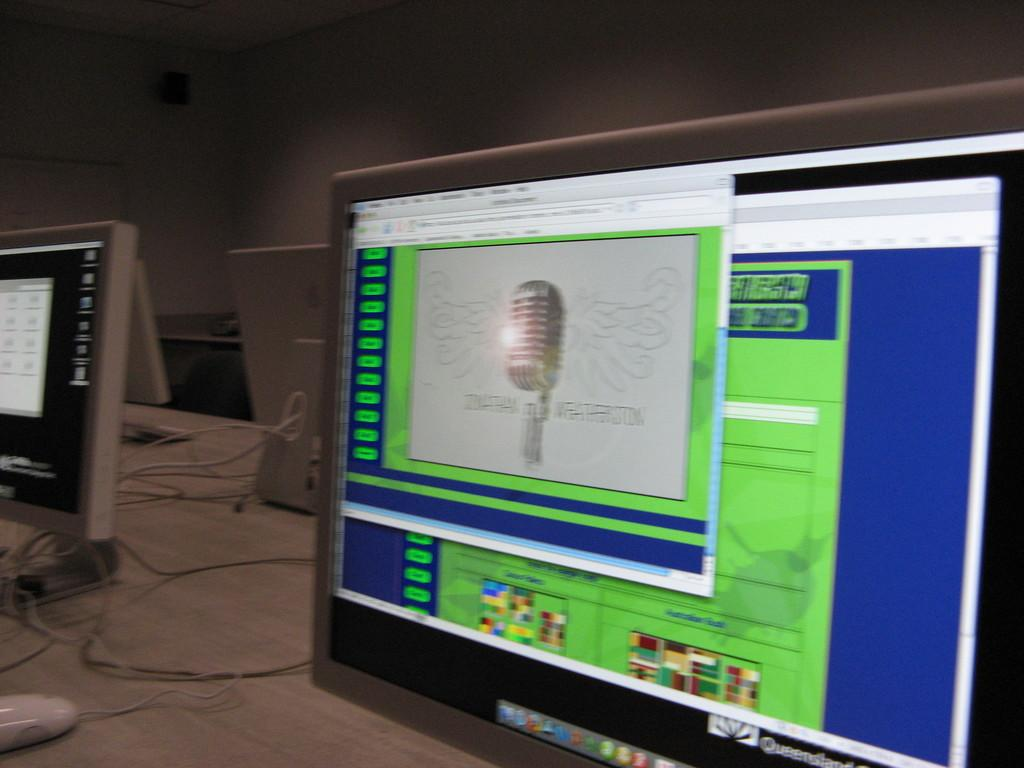What electronic devices are visible in the image? There are monitors in the image. What is used for input with the monitors? There is a mouse in the image. What connects the devices in the image? There are cables in the image. What can be seen in the background of the image? There is a wall in the background of the image. Can you tell me how many chess pieces are on the island in the image? There is no island or chess pieces present in the image; it features electronic devices and a wall in the background. What type of skin is visible on the monitors in the image? The monitors in the image are electronic devices and do not have skin. 